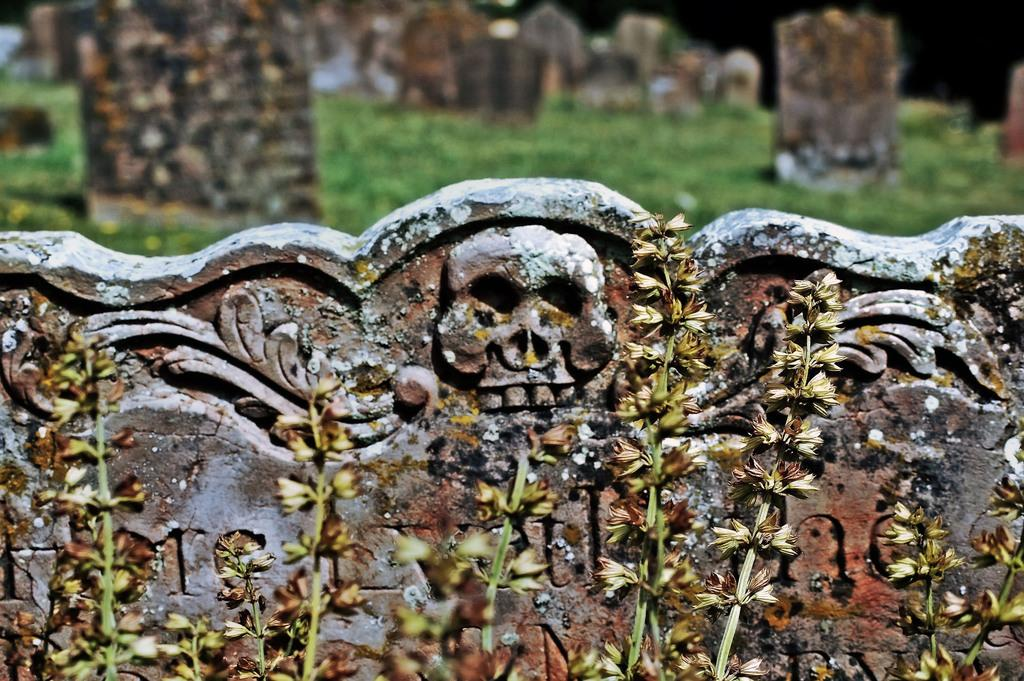What is depicted on the wall in the image? There is a wall with sculptures in the image. What type of vegetation is present at the bottom of the image? There are: There are plants with flowers at the bottom of the image. What can be seen on the grassland at the top of the image? There are cemeteries on the grassland at the top of the image. What is the purpose of the snakes in the image? There are no snakes present in the image. What is the income of the person who created the sculptures in the image? The income of the person who created the sculptures is not mentioned or visible in the image. 